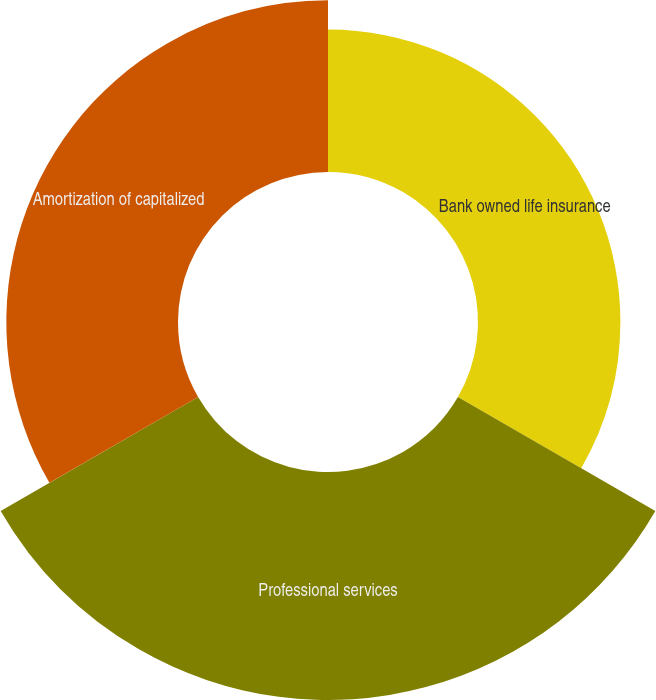Convert chart. <chart><loc_0><loc_0><loc_500><loc_500><pie_chart><fcel>Bank owned life insurance<fcel>Professional services<fcel>Amortization of capitalized<nl><fcel>26.27%<fcel>42.06%<fcel>31.67%<nl></chart> 